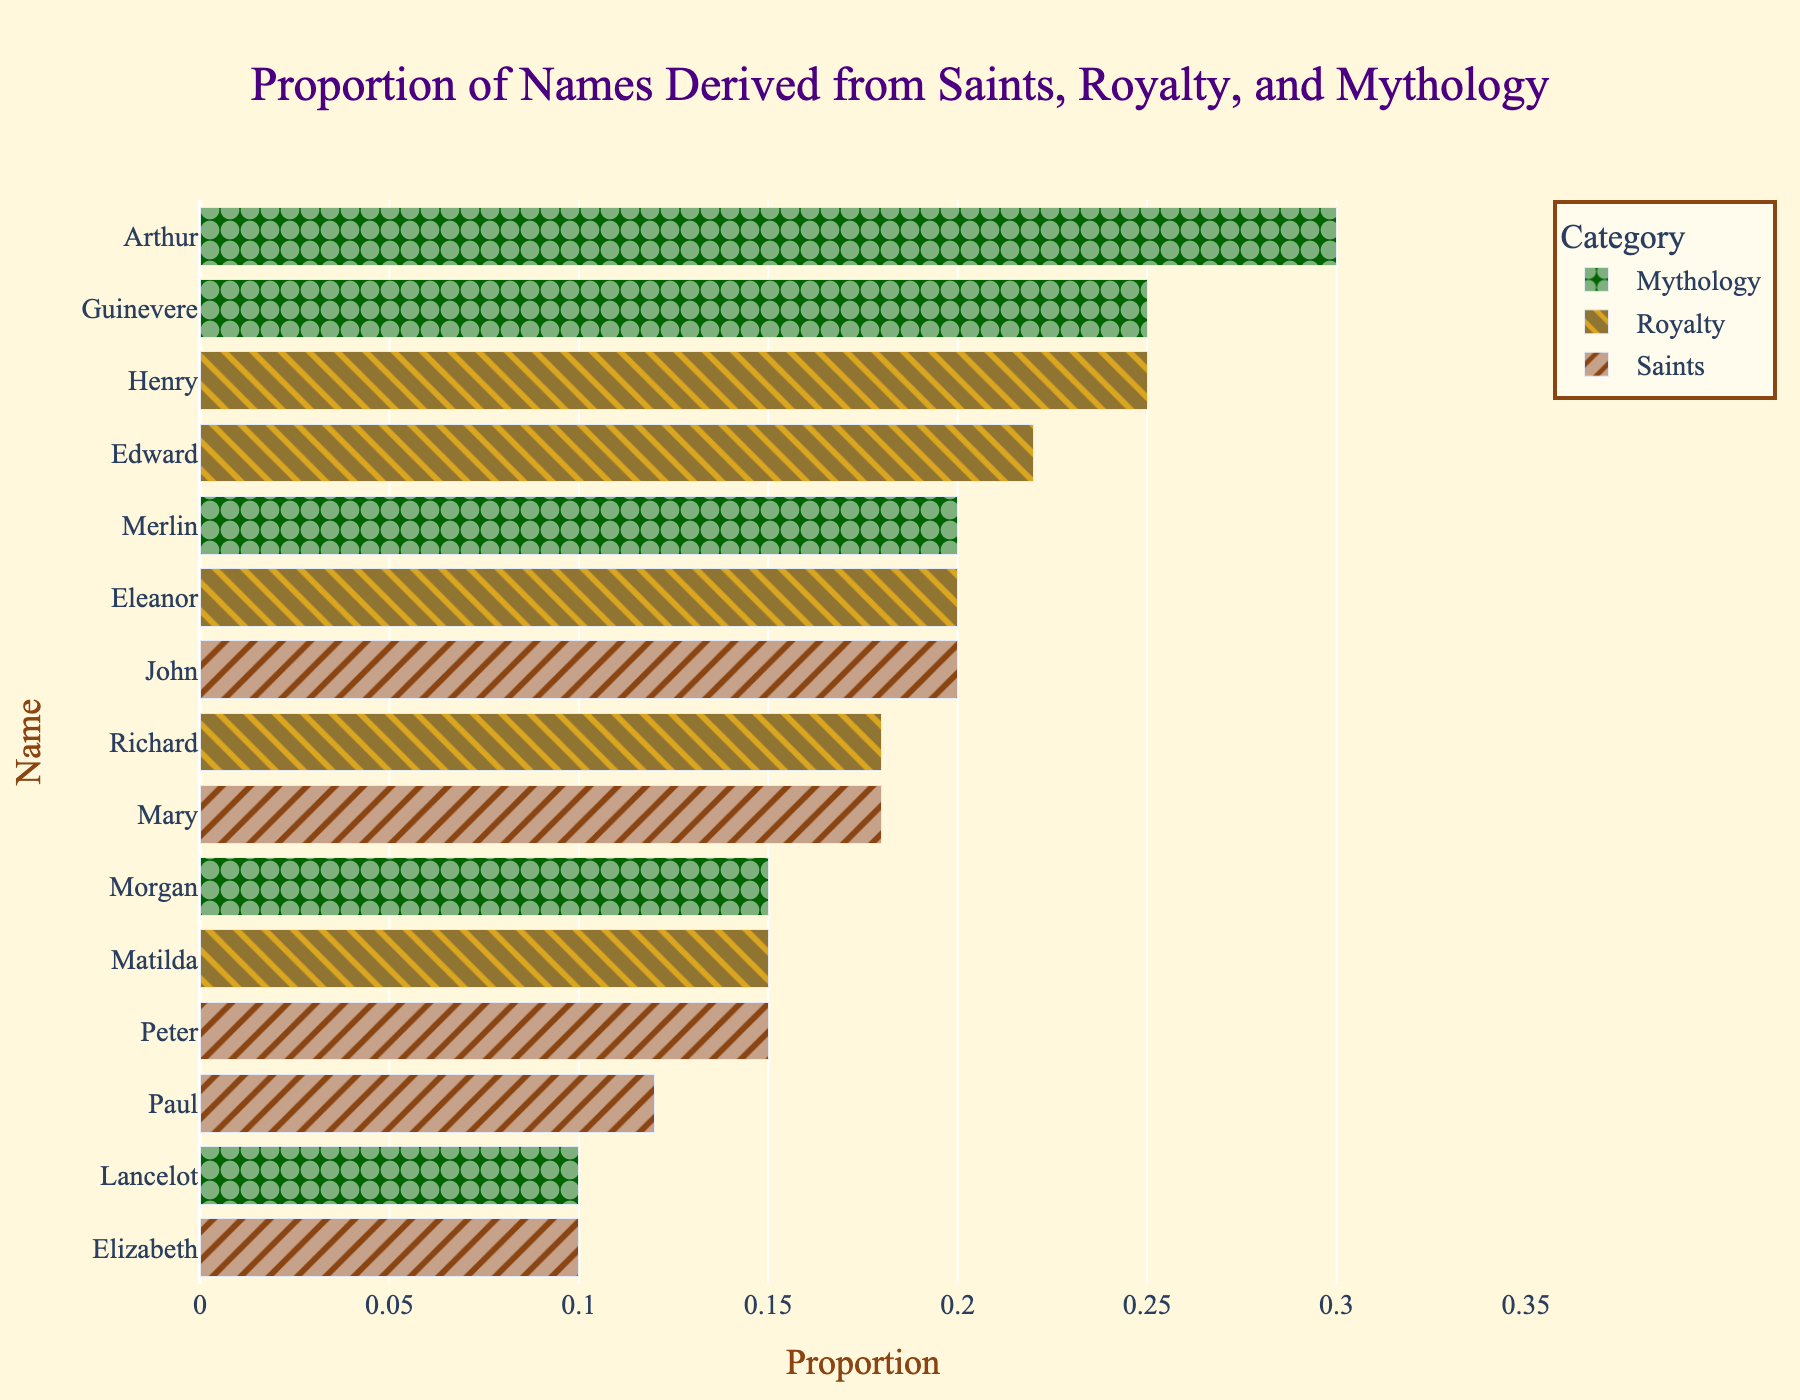Which category has the highest total proportion? The total proportion is the sum of all proportions for each category. For Saints: 0.20 + 0.18 + 0.15 + 0.12 + 0.10 = 0.75, for Royalty: 0.25 + 0.22 + 0.20 + 0.18 + 0.15 = 1.0, for Mythology: 0.30 + 0.25 + 0.20 + 0.15 + 0.10 = 1.0. Both Mythology and Royalty categories have the highest total proportion of 1.0.
Answer: Royalty and Mythology What is the proportion difference between the names Henry and Morgan? Henry has a proportion of 0.25, and Morgan has a proportion of 0.15. The difference between the two proportions is 0.25 - 0.15 = 0.10.
Answer: 0.10 Which name derived from Saints has the smallest proportion? To find the smallest proportion, we compare the proportions for the names from the Saints category: John (0.20), Mary (0.18), Peter (0.15), Paul (0.12), and Elizabeth (0.10). The smallest proportion is 0.10 for Elizabeth.
Answer: Elizabeth Are there more names derived from mythology or royalty in the dataset? Both Mythology and Royalty categories have five names each, so the number of names derived from mythology and royalty is equal.
Answer: Equal Which name has the highest proportion in the Mythology category? The proportions of the names in the Mythology category are Arthur (0.30), Guinevere (0.25), Merlin (0.20), Morgan (0.15), and Lancelot (0.10). The highest proportion is 0.30 for Arthur.
Answer: Arthur What is the average proportion for names derived from Saints? Sum the proportions for names derived from Saints and divide by the number of names: (0.20 + 0.18 + 0.15 + 0.12 + 0.10) / 5 = 0.75 / 5 = 0.15.
Answer: 0.15 If you combine the proportions of John and Elizabeth, would it exceed the proportion of Henry? The proportions of John and Elizabeth are 0.20 and 0.10 respectively. Adding them gives 0.20 + 0.10 = 0.30. Since the proportion of Henry is 0.25, the combined proportion of John and Elizabeth exceeds Henry's.
Answer: Yes Which names derived from Royalty have proportions higher than 0.20? The names in the Royalty category with their proportions are: Henry (0.25), Edward (0.22), Eleanor (0.20), Richard (0.18), and Matilda (0.15). Henry (0.25) and Edward (0.22) have proportions higher than 0.20.
Answer: Henry and Edward Is Peter more prevalent than Matilda based on proportion? The proportion for Peter is 0.15, and for Matilda is also 0.15. Hence, they are equally prevalent.
Answer: Equal 